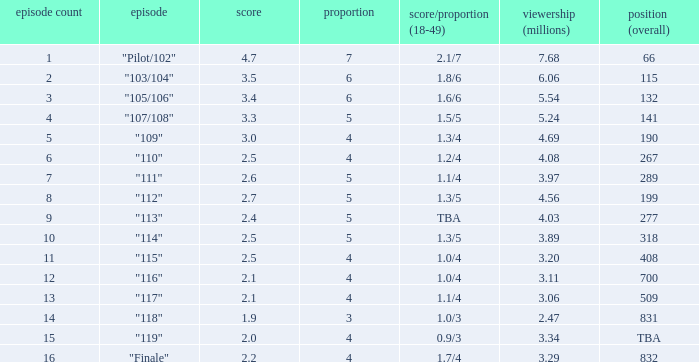WHAT IS THE RATING THAT HAD A SHARE SMALLER THAN 4, AND 2.47 MILLION VIEWERS? 0.0. 